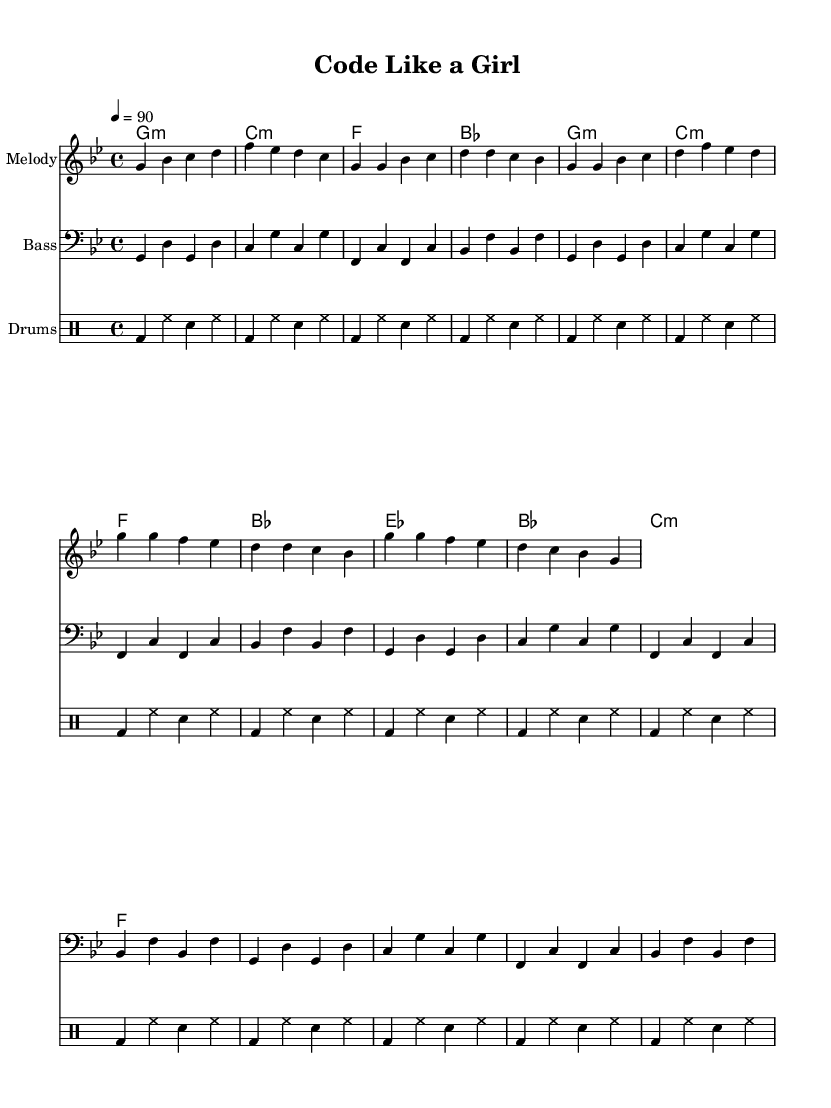What is the time signature of this music? The time signature is found at the beginning of the sheet music and indicates the rhythmic structure. In this case, it shows a 4/4 time signature, meaning there are four beats per measure and a quarter note gets one beat.
Answer: 4/4 What is the key signature of this music? To identify the key signature, we look at the key indicated in the global section of the score. Here, it is set in G minor, which has two flats: B flat and E flat.
Answer: G minor What is the tempo marking for this piece? The tempo marking is specified in the global section, given as a number that indicates the speed of the piece. This score indicates a tempo of 90 beats per minute.
Answer: 90 How many measures are there in the melody section? The melody section can be counted by looking at the measures provided in the melody staff. There are five measures in total based on the notation given.
Answer: 5 Which type of drum is used in the drum part? The drum part refers to the various percussive instruments. In the given drum notation, it explicitly mentions the use of a bass drum (bd), hi-hat (hh), and snare (sn), indicating these types of drums are featured.
Answer: Bass drum What is the chord progression of the Chorus section? To find the chord progression in the Chorus, we examine the harmonic section. The chords played in the Chorus are E flat major, B flat major, C minor, and F major, which is the sequence noted for that section.
Answer: E flat major, B flat major, C minor, F major Which element in this piece highlights the theme of Gender Gap in STEM? The overall subject matter of this rap piece addresses social issues specifically pertaining to the gender gap in STEM fields, as indicated in the title and lyrical themes throughout the music.
Answer: Gender gap in STEM 